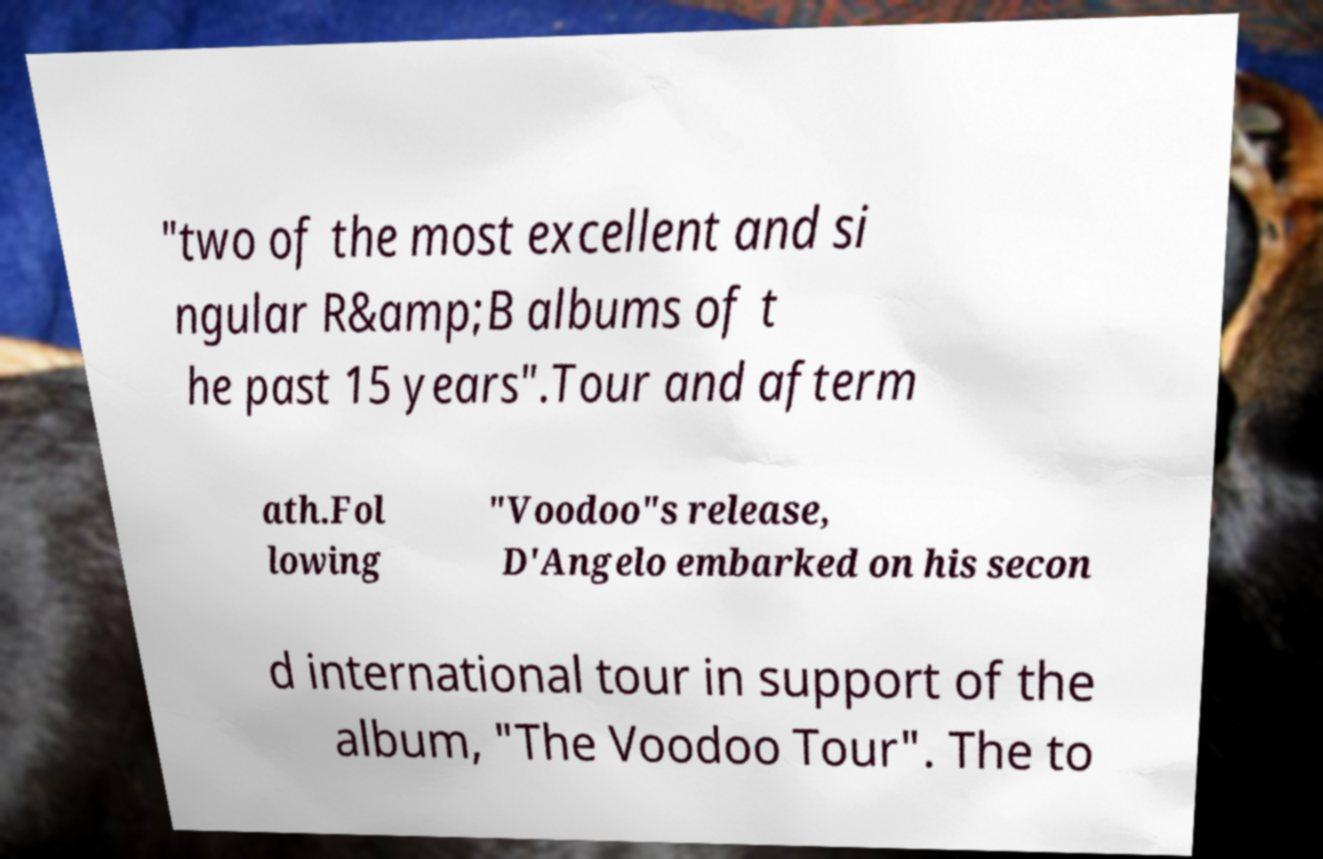What messages or text are displayed in this image? I need them in a readable, typed format. "two of the most excellent and si ngular R&amp;B albums of t he past 15 years".Tour and afterm ath.Fol lowing "Voodoo"s release, D'Angelo embarked on his secon d international tour in support of the album, "The Voodoo Tour". The to 